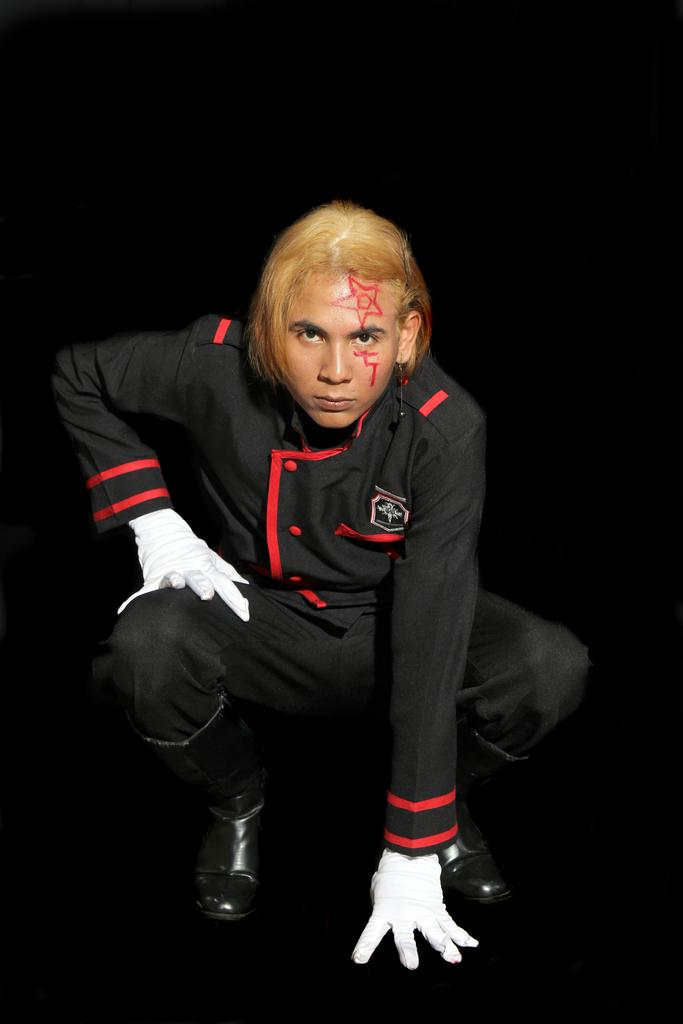Who or what is the main subject in the image? There is a person in the image. What is the person wearing? The person is wearing a black and red colored dress and white colored gloves. What color is the background of the image? The background of the image is black. Can you tell me how many properties the person is walking on in the image? There is no indication of the person walking on any properties in the image. 